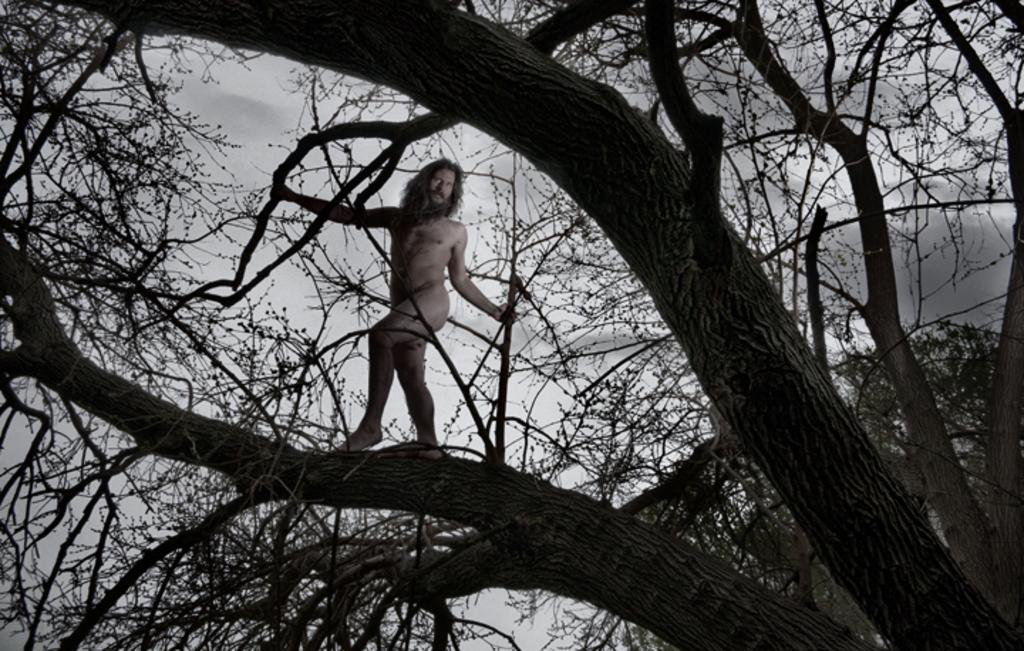What is the color scheme of the image? The image is black and white. When was the image taken? The image was taken in the dark. What natural element can be seen in the image? There is a tree in the image. What is the person in the image doing? There is a nude person standing on a branch of the tree. What type of roll can be seen in the image? There is no roll present in the image. What scene is depicted in the image? The image depicts a nude person standing on a branch of a tree in the dark. 